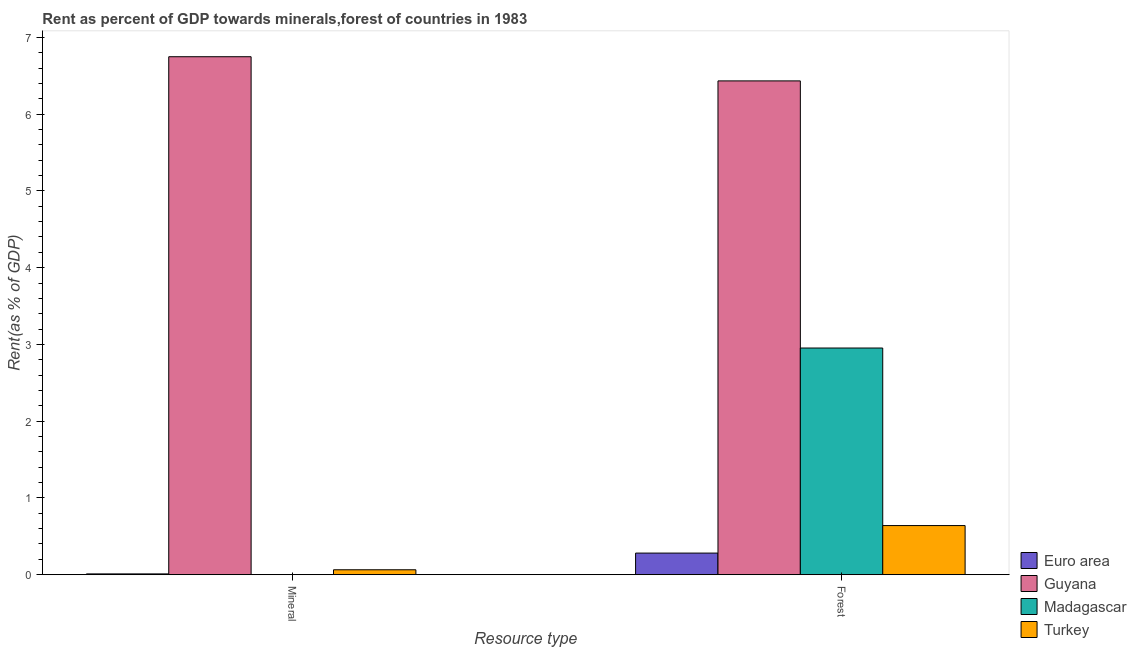How many groups of bars are there?
Your answer should be compact. 2. Are the number of bars on each tick of the X-axis equal?
Give a very brief answer. Yes. How many bars are there on the 1st tick from the left?
Your response must be concise. 4. What is the label of the 1st group of bars from the left?
Offer a very short reply. Mineral. What is the forest rent in Madagascar?
Ensure brevity in your answer.  2.95. Across all countries, what is the maximum mineral rent?
Ensure brevity in your answer.  6.75. Across all countries, what is the minimum mineral rent?
Provide a succinct answer. 0. In which country was the forest rent maximum?
Your answer should be compact. Guyana. In which country was the mineral rent minimum?
Ensure brevity in your answer.  Madagascar. What is the total forest rent in the graph?
Offer a very short reply. 10.31. What is the difference between the forest rent in Euro area and that in Guyana?
Ensure brevity in your answer.  -6.15. What is the difference between the mineral rent in Guyana and the forest rent in Madagascar?
Provide a short and direct response. 3.79. What is the average mineral rent per country?
Offer a very short reply. 1.71. What is the difference between the mineral rent and forest rent in Turkey?
Your response must be concise. -0.58. What is the ratio of the mineral rent in Turkey to that in Guyana?
Offer a terse response. 0.01. In how many countries, is the forest rent greater than the average forest rent taken over all countries?
Make the answer very short. 2. What does the 1st bar from the left in Forest represents?
Make the answer very short. Euro area. What does the 1st bar from the right in Forest represents?
Offer a very short reply. Turkey. How many bars are there?
Offer a terse response. 8. Are all the bars in the graph horizontal?
Offer a very short reply. No. Does the graph contain any zero values?
Provide a short and direct response. No. Does the graph contain grids?
Your answer should be very brief. No. Where does the legend appear in the graph?
Give a very brief answer. Bottom right. How many legend labels are there?
Your answer should be very brief. 4. What is the title of the graph?
Ensure brevity in your answer.  Rent as percent of GDP towards minerals,forest of countries in 1983. What is the label or title of the X-axis?
Offer a terse response. Resource type. What is the label or title of the Y-axis?
Give a very brief answer. Rent(as % of GDP). What is the Rent(as % of GDP) of Euro area in Mineral?
Your response must be concise. 0.01. What is the Rent(as % of GDP) in Guyana in Mineral?
Offer a terse response. 6.75. What is the Rent(as % of GDP) in Madagascar in Mineral?
Ensure brevity in your answer.  0. What is the Rent(as % of GDP) of Turkey in Mineral?
Provide a succinct answer. 0.06. What is the Rent(as % of GDP) in Euro area in Forest?
Give a very brief answer. 0.28. What is the Rent(as % of GDP) in Guyana in Forest?
Offer a very short reply. 6.43. What is the Rent(as % of GDP) in Madagascar in Forest?
Offer a very short reply. 2.95. What is the Rent(as % of GDP) of Turkey in Forest?
Provide a succinct answer. 0.64. Across all Resource type, what is the maximum Rent(as % of GDP) of Euro area?
Offer a terse response. 0.28. Across all Resource type, what is the maximum Rent(as % of GDP) of Guyana?
Offer a terse response. 6.75. Across all Resource type, what is the maximum Rent(as % of GDP) of Madagascar?
Your response must be concise. 2.95. Across all Resource type, what is the maximum Rent(as % of GDP) of Turkey?
Make the answer very short. 0.64. Across all Resource type, what is the minimum Rent(as % of GDP) of Euro area?
Give a very brief answer. 0.01. Across all Resource type, what is the minimum Rent(as % of GDP) of Guyana?
Ensure brevity in your answer.  6.43. Across all Resource type, what is the minimum Rent(as % of GDP) of Madagascar?
Your answer should be very brief. 0. Across all Resource type, what is the minimum Rent(as % of GDP) of Turkey?
Your response must be concise. 0.06. What is the total Rent(as % of GDP) of Euro area in the graph?
Offer a terse response. 0.29. What is the total Rent(as % of GDP) in Guyana in the graph?
Your response must be concise. 13.18. What is the total Rent(as % of GDP) in Madagascar in the graph?
Offer a terse response. 2.95. What is the total Rent(as % of GDP) of Turkey in the graph?
Offer a very short reply. 0.7. What is the difference between the Rent(as % of GDP) of Euro area in Mineral and that in Forest?
Ensure brevity in your answer.  -0.27. What is the difference between the Rent(as % of GDP) in Guyana in Mineral and that in Forest?
Ensure brevity in your answer.  0.32. What is the difference between the Rent(as % of GDP) in Madagascar in Mineral and that in Forest?
Your answer should be very brief. -2.95. What is the difference between the Rent(as % of GDP) of Turkey in Mineral and that in Forest?
Your answer should be very brief. -0.58. What is the difference between the Rent(as % of GDP) in Euro area in Mineral and the Rent(as % of GDP) in Guyana in Forest?
Offer a very short reply. -6.42. What is the difference between the Rent(as % of GDP) of Euro area in Mineral and the Rent(as % of GDP) of Madagascar in Forest?
Keep it short and to the point. -2.94. What is the difference between the Rent(as % of GDP) of Euro area in Mineral and the Rent(as % of GDP) of Turkey in Forest?
Your answer should be very brief. -0.63. What is the difference between the Rent(as % of GDP) of Guyana in Mineral and the Rent(as % of GDP) of Madagascar in Forest?
Offer a terse response. 3.79. What is the difference between the Rent(as % of GDP) of Guyana in Mineral and the Rent(as % of GDP) of Turkey in Forest?
Provide a succinct answer. 6.11. What is the difference between the Rent(as % of GDP) of Madagascar in Mineral and the Rent(as % of GDP) of Turkey in Forest?
Offer a very short reply. -0.64. What is the average Rent(as % of GDP) in Euro area per Resource type?
Your response must be concise. 0.15. What is the average Rent(as % of GDP) of Guyana per Resource type?
Your response must be concise. 6.59. What is the average Rent(as % of GDP) of Madagascar per Resource type?
Provide a short and direct response. 1.48. What is the average Rent(as % of GDP) in Turkey per Resource type?
Provide a short and direct response. 0.35. What is the difference between the Rent(as % of GDP) of Euro area and Rent(as % of GDP) of Guyana in Mineral?
Offer a very short reply. -6.74. What is the difference between the Rent(as % of GDP) in Euro area and Rent(as % of GDP) in Madagascar in Mineral?
Keep it short and to the point. 0.01. What is the difference between the Rent(as % of GDP) in Euro area and Rent(as % of GDP) in Turkey in Mineral?
Provide a succinct answer. -0.05. What is the difference between the Rent(as % of GDP) of Guyana and Rent(as % of GDP) of Madagascar in Mineral?
Your answer should be very brief. 6.75. What is the difference between the Rent(as % of GDP) of Guyana and Rent(as % of GDP) of Turkey in Mineral?
Provide a short and direct response. 6.68. What is the difference between the Rent(as % of GDP) of Madagascar and Rent(as % of GDP) of Turkey in Mineral?
Make the answer very short. -0.06. What is the difference between the Rent(as % of GDP) of Euro area and Rent(as % of GDP) of Guyana in Forest?
Provide a short and direct response. -6.15. What is the difference between the Rent(as % of GDP) of Euro area and Rent(as % of GDP) of Madagascar in Forest?
Give a very brief answer. -2.67. What is the difference between the Rent(as % of GDP) of Euro area and Rent(as % of GDP) of Turkey in Forest?
Ensure brevity in your answer.  -0.36. What is the difference between the Rent(as % of GDP) of Guyana and Rent(as % of GDP) of Madagascar in Forest?
Keep it short and to the point. 3.48. What is the difference between the Rent(as % of GDP) in Guyana and Rent(as % of GDP) in Turkey in Forest?
Provide a succinct answer. 5.79. What is the difference between the Rent(as % of GDP) of Madagascar and Rent(as % of GDP) of Turkey in Forest?
Give a very brief answer. 2.31. What is the ratio of the Rent(as % of GDP) of Euro area in Mineral to that in Forest?
Give a very brief answer. 0.04. What is the ratio of the Rent(as % of GDP) in Guyana in Mineral to that in Forest?
Make the answer very short. 1.05. What is the ratio of the Rent(as % of GDP) of Madagascar in Mineral to that in Forest?
Give a very brief answer. 0. What is the ratio of the Rent(as % of GDP) of Turkey in Mineral to that in Forest?
Make the answer very short. 0.1. What is the difference between the highest and the second highest Rent(as % of GDP) in Euro area?
Ensure brevity in your answer.  0.27. What is the difference between the highest and the second highest Rent(as % of GDP) in Guyana?
Offer a very short reply. 0.32. What is the difference between the highest and the second highest Rent(as % of GDP) of Madagascar?
Offer a terse response. 2.95. What is the difference between the highest and the second highest Rent(as % of GDP) of Turkey?
Provide a succinct answer. 0.58. What is the difference between the highest and the lowest Rent(as % of GDP) of Euro area?
Give a very brief answer. 0.27. What is the difference between the highest and the lowest Rent(as % of GDP) of Guyana?
Offer a very short reply. 0.32. What is the difference between the highest and the lowest Rent(as % of GDP) in Madagascar?
Keep it short and to the point. 2.95. What is the difference between the highest and the lowest Rent(as % of GDP) of Turkey?
Provide a succinct answer. 0.58. 